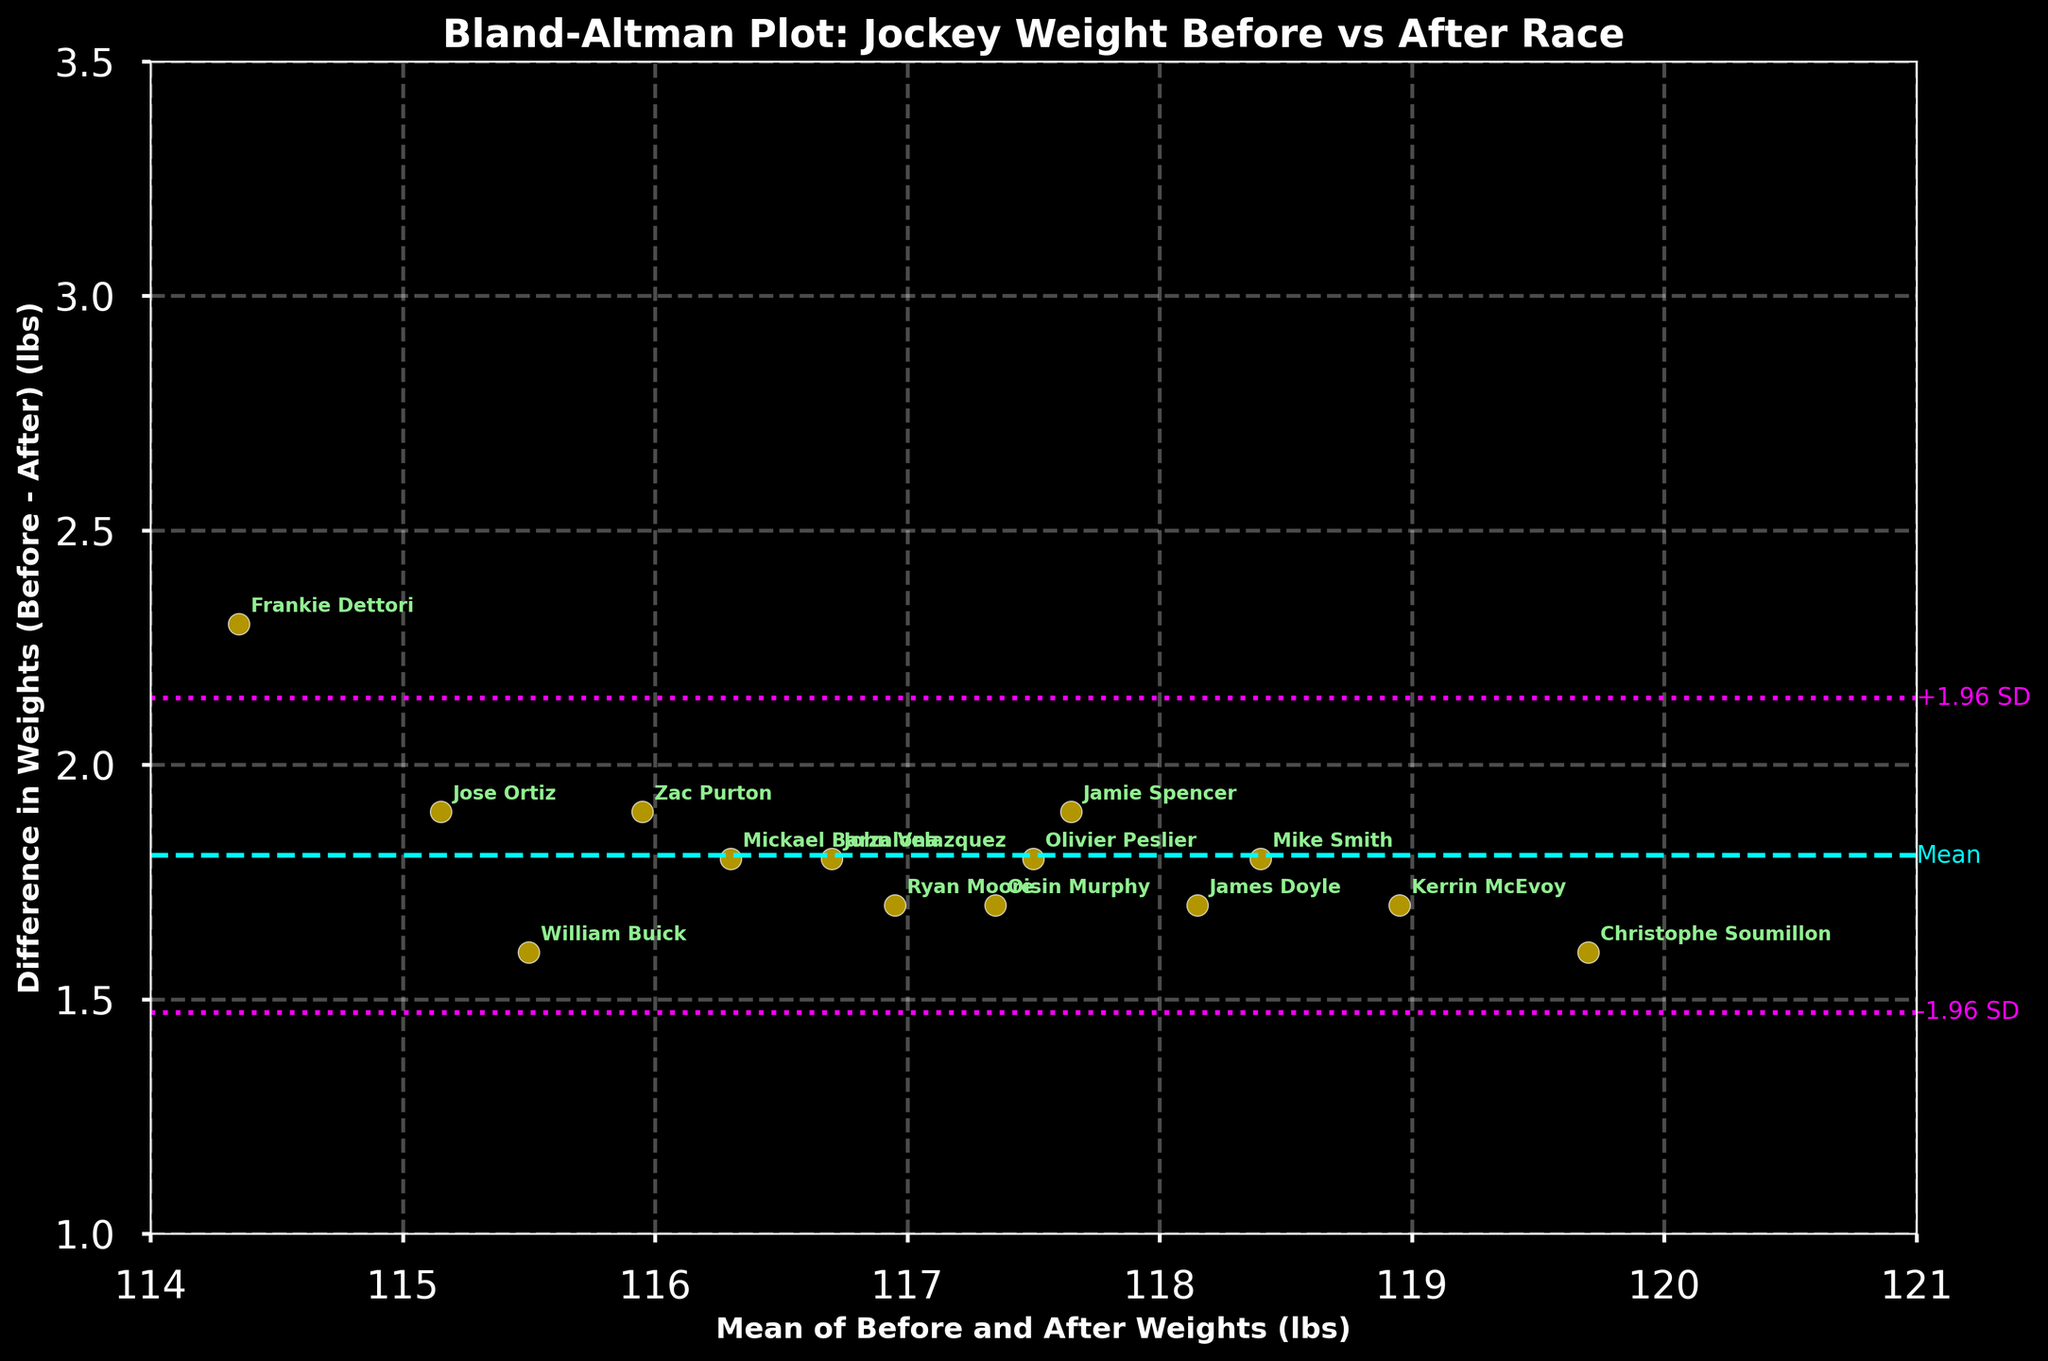What do the cyan and magenta lines represent in the plot? The cyan line represents the mean difference in weights before and after races, while the magenta lines represent the limits of agreement, at ±1.96 standard deviations from the mean difference.
Answer: Cyan: mean, Magenta: limits of agreement What is the title of the plot? The title can be identified at the top of the figure. It reads "Bland-Altman Plot: Jockey Weight Before vs After Race".
Answer: Bland-Altman Plot: Jockey Weight Before vs After Race How many data points (jockeys) are there in the plot? By counting each individual scatter point in the plot, it can be determined that there are 15 data points corresponding to 15 jockeys.
Answer: 15 What does the x-axis represent? The x-axis in the plot represents the mean of weights before and after races for the jockeys, displayed in pounds (lbs).
Answer: Mean of Before and After Weights (lbs) What does the y-axis represent? The y-axis shows the difference in weights (Before - After) for the jockeys, also displayed in pounds (lbs).
Answer: Difference in Weights (Before - After) (lbs) Within what range do the limits of agreement fall? The limits of agreement are marked by the magenta lines, representing ±1.96 standard deviations from the mean difference. They fall between roughly 1.6 and 2.8 on the y-axis.
Answer: 1.6 to 2.8 Which jockey experienced the greatest weight fluctuation? Looking at the plot, Christophe Soumillon's point is the highest on the y-axis, indicating the greatest difference in weights before and after races.
Answer: Christophe Soumillon Which jockey has the smallest fluctuation in weight? By identifying the point closest to the x-axis (y=0), Zac Purton's point is the lowest, indicating that his weight fluctuation was the smallest.
Answer: Zac Purton Are all weight differences positive? Each point lies above the x-axis (positive y-values), indicating all the weights decreased after the races.
Answer: Yes How would you describe the trend in the weight differences relative to the mean weights? The weight differences do not show a systematic trend; they appear to be fairly consistent across the range of mean weights, as there is no evident pattern or slope.
Answer: No evident pattern 